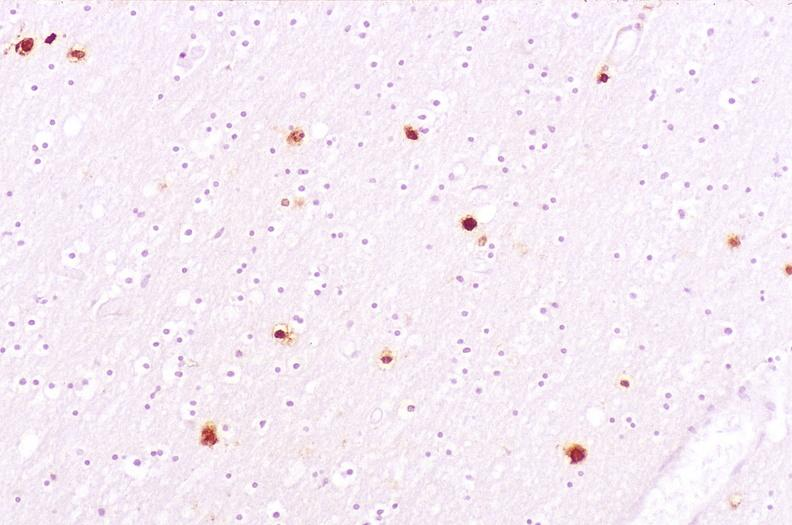what does this image show?
Answer the question using a single word or phrase. Brain 